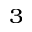<formula> <loc_0><loc_0><loc_500><loc_500>_ { 3 }</formula> 